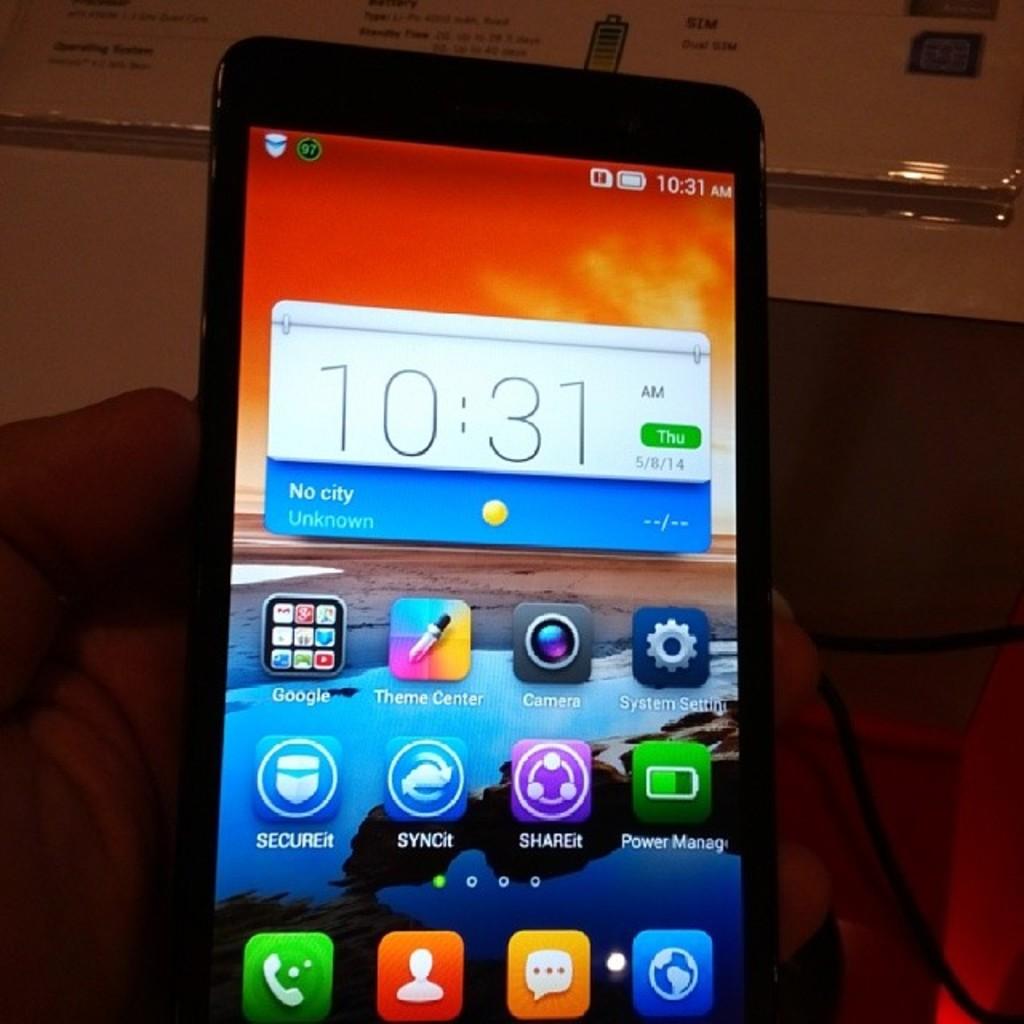What time is on the phone?
Make the answer very short. 10:31. 